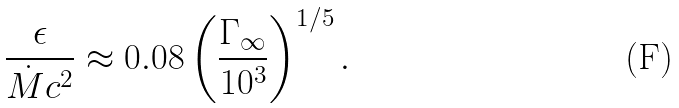Convert formula to latex. <formula><loc_0><loc_0><loc_500><loc_500>\frac { \epsilon } { \dot { M } c ^ { 2 } } \approx 0 . 0 8 \left ( \frac { \Gamma _ { \infty } } { 1 0 ^ { 3 } } \right ) ^ { 1 / 5 } .</formula> 